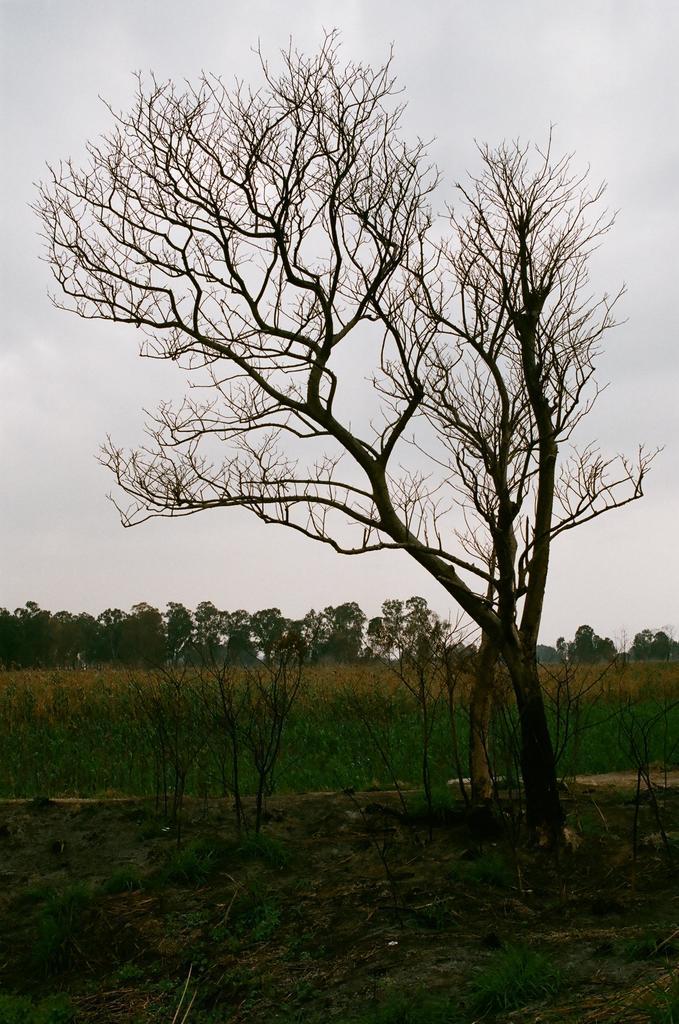Describe this image in one or two sentences. In the foreground of this picture, there is a tree on the ground. In the background, we can see plants, trees and the sky. 